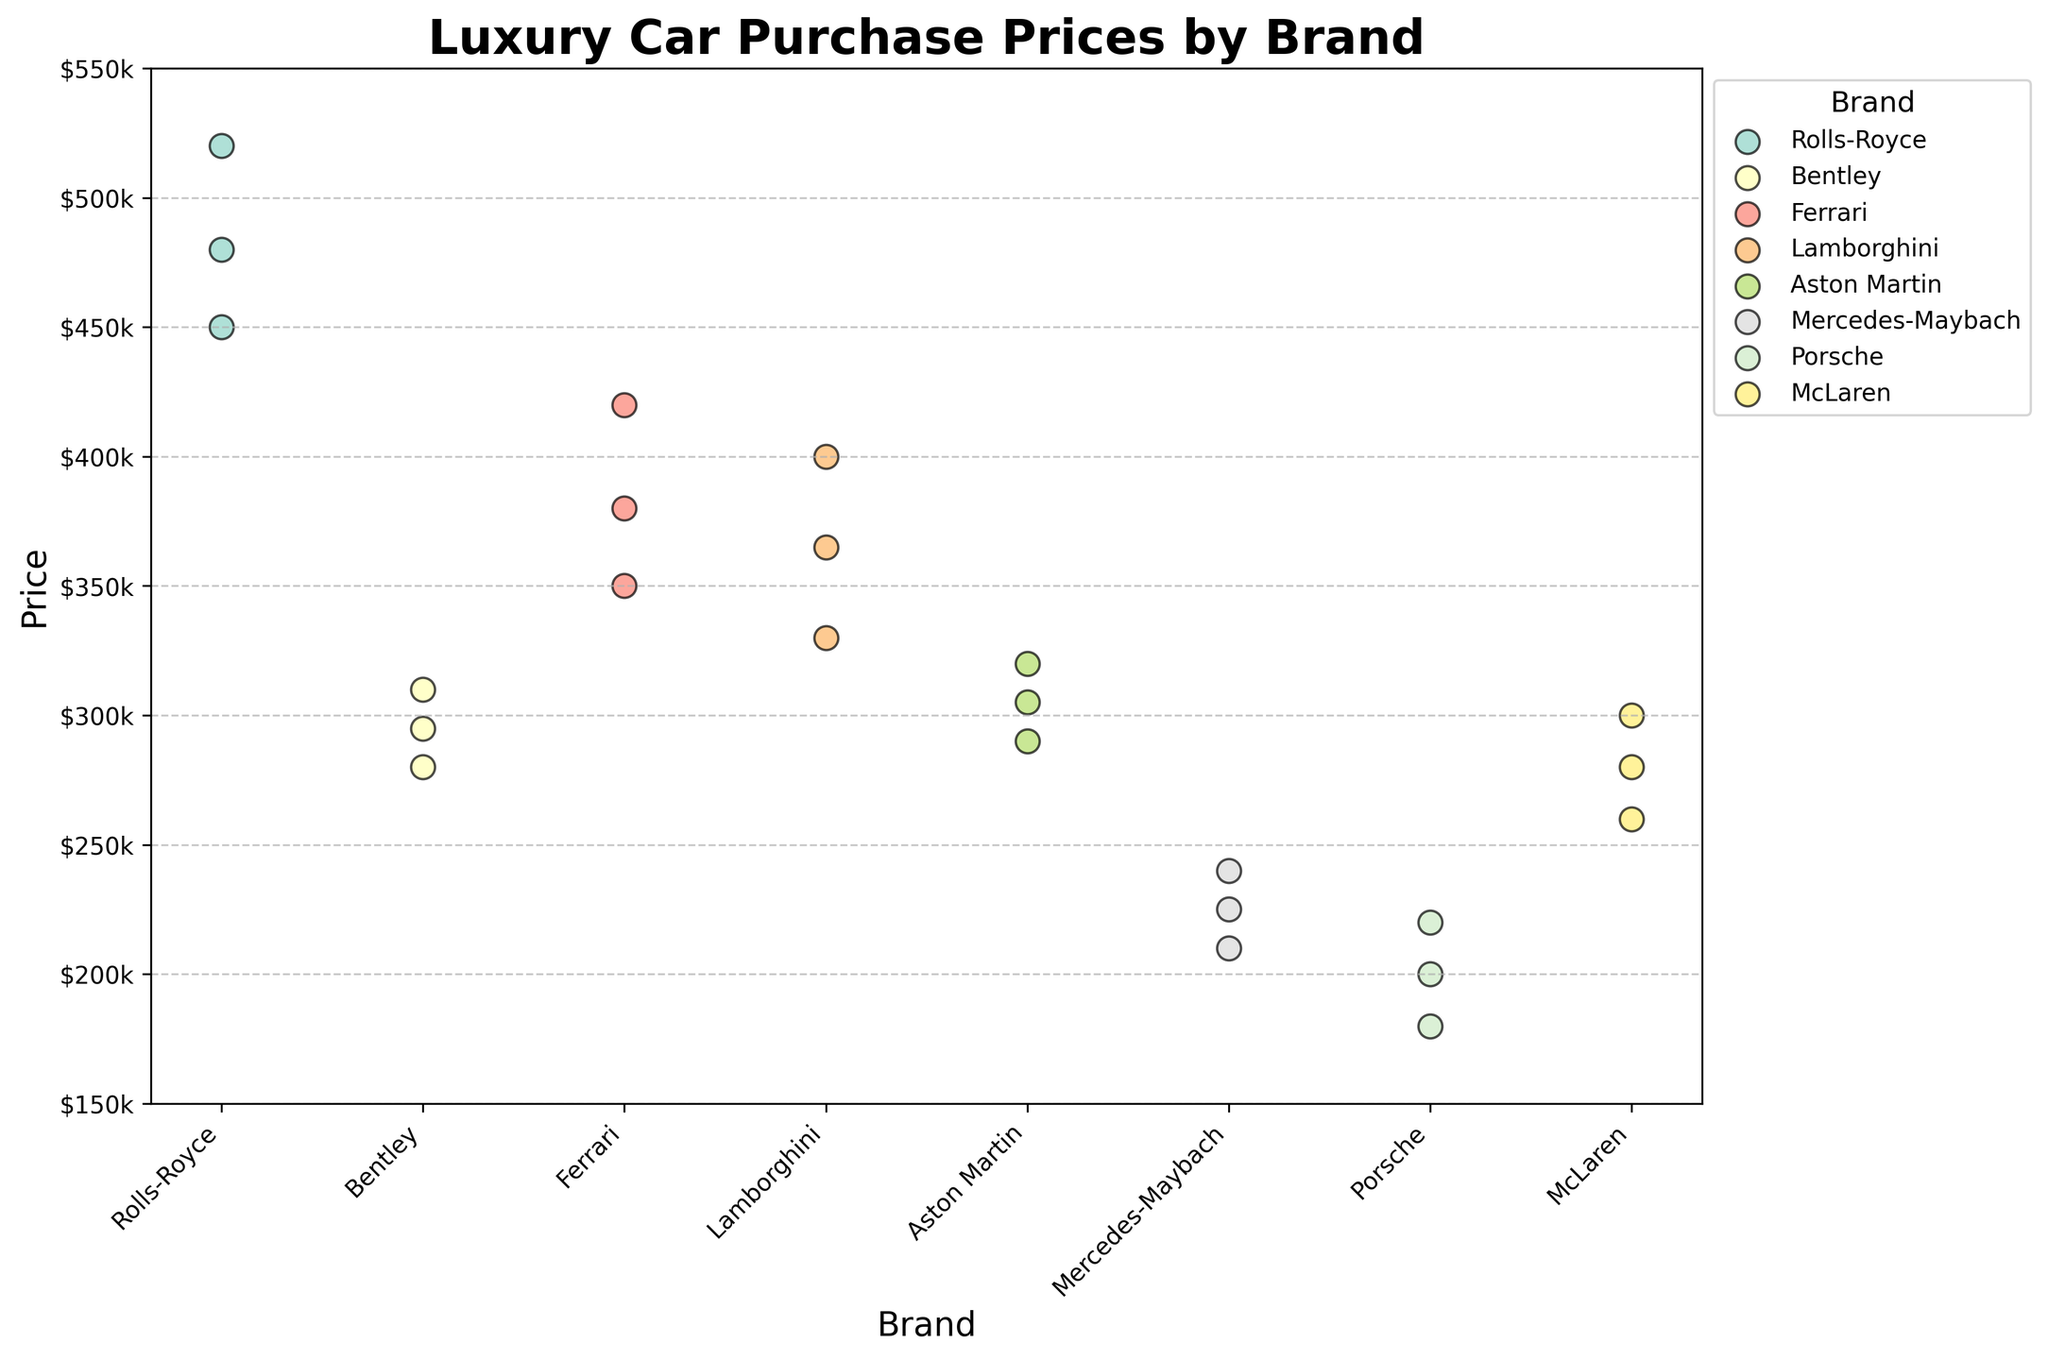What's the title of the chart? The title of the chart is displayed at the top of the figure, and it is clearly labeled.
Answer: Luxury Car Purchase Prices by Brand How many different brands are represented in the plot? The x-axis shows each unique brand as a separate label. Count the labels to determine the number of brands.
Answer: 8 Which brand has the highest maximum price? Look for the highest data point on the y-axis and identify which brand it belongs to.
Answer: Rolls-Royce What is the average price of Ferrari cars? Identify the Ferrari data points, add their prices (350000 + 420000 + 380000), and divide by the number of points (3).
Answer: 383,333.33 Which brand has the least variability in car prices? Compare the spread of the data points for each brand. The least spread indicates the least variability.
Answer: Porsche Which two brands have the closest average purchase price? Calculate the average price for each brand, then compare to find the two brands with the smallest difference.
Answer: Bentley and Aston Martin Do any brands have overlapping price ranges? Check if there are data points from different brands that fall within the same range on the y-axis.
Answer: Yes What is the price range for Mercedes-Maybach cars? Identify the highest and lowest data points for Mercedes-Maybach and calculate the range.
Answer: $210,000 - $240,000 Which brand has the most similarly-priced cars? Look for the brand where data points cluster close together on the y-axis.
Answer: Mercedes-Maybach 